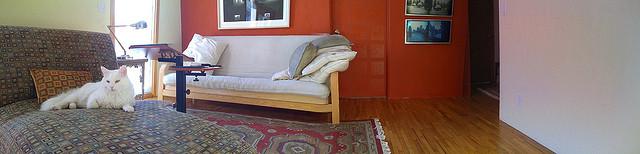Is there any plants in the room?
Answer briefly. No. How many pillows are on the couch?
Keep it brief. 4. What animal do you see?
Answer briefly. Cat. 